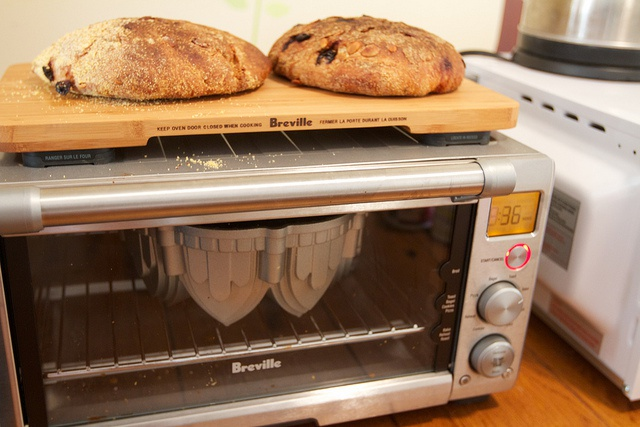Describe the objects in this image and their specific colors. I can see oven in tan, black, gray, and maroon tones, microwave in tan, lightgray, and darkgray tones, cake in tan, red, and salmon tones, and cake in tan, orange, brown, red, and salmon tones in this image. 